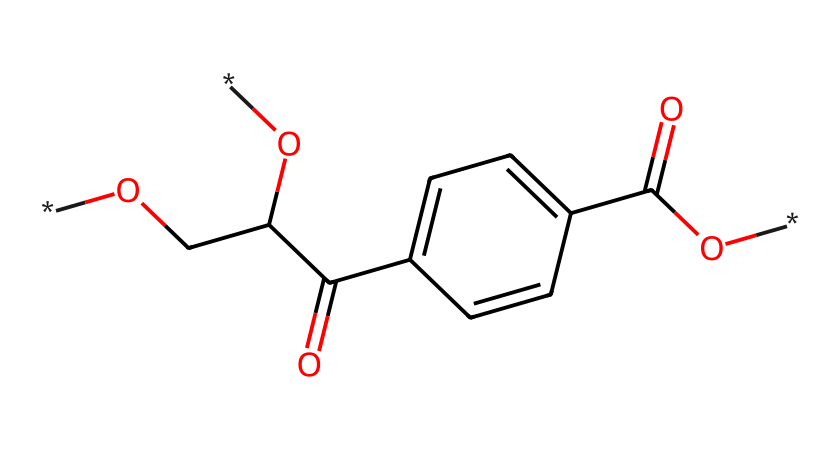What is the molecular formula of polyethylene terephthalate? By analyzing the SMILES, the number of carbon (C), hydrogen (H), and oxygen (O) atoms can be counted: there are 10 carbon atoms, 8 hydrogen atoms, and 4 oxygen atoms, forming the molecular formula C10H8O4.
Answer: C10H8O4 How many carbon atoms are in this structure? Counting the 'C' atoms in the SMILES representation reveals there are 10 carbon atoms present in the structure.
Answer: 10 What type of functional group is present in polyethylene terephthalate? The presence of the carboxyl groups (-COOH and -C(=O)O) indicates that this compound contains carboxyl functional groups, making it an ester.
Answer: ester How many double bonds are there in this molecule? By examining the SMILES structure, there are 2 double bonds represented by '=' in the carbonyl groups (C=O) of the carboxyl moieties, indicating a total of 2 double bonds.
Answer: 2 Does polyethylene terephthalate have any aromatic components? The presence of the 'c' symbols in the SMILES indicates that there are aromatic rings present, signifying that this compound does contain aromatic components.
Answer: yes What is the role of ester bonds in this molecule? The ester bonds, formed between the alcohol and the acid components, are responsible for linking the repeating units together in polyethylene terephthalate, giving it its structure and properties.
Answer: linking units 